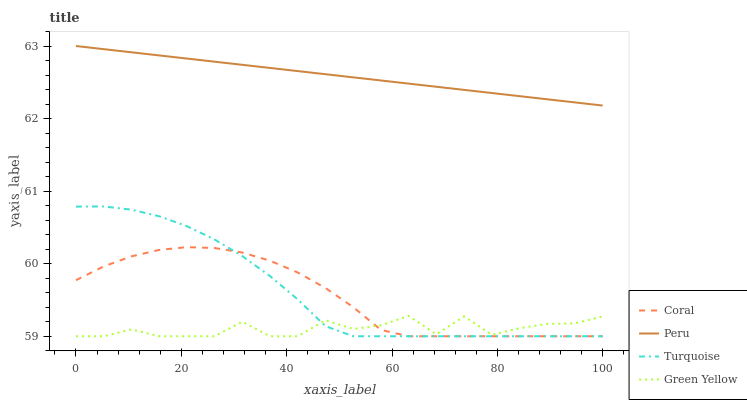Does Green Yellow have the minimum area under the curve?
Answer yes or no. Yes. Does Peru have the maximum area under the curve?
Answer yes or no. Yes. Does Turquoise have the minimum area under the curve?
Answer yes or no. No. Does Turquoise have the maximum area under the curve?
Answer yes or no. No. Is Peru the smoothest?
Answer yes or no. Yes. Is Green Yellow the roughest?
Answer yes or no. Yes. Is Turquoise the smoothest?
Answer yes or no. No. Is Turquoise the roughest?
Answer yes or no. No. Does Peru have the lowest value?
Answer yes or no. No. Does Peru have the highest value?
Answer yes or no. Yes. Does Turquoise have the highest value?
Answer yes or no. No. Is Turquoise less than Peru?
Answer yes or no. Yes. Is Peru greater than Coral?
Answer yes or no. Yes. Does Green Yellow intersect Turquoise?
Answer yes or no. Yes. Is Green Yellow less than Turquoise?
Answer yes or no. No. Is Green Yellow greater than Turquoise?
Answer yes or no. No. Does Turquoise intersect Peru?
Answer yes or no. No. 